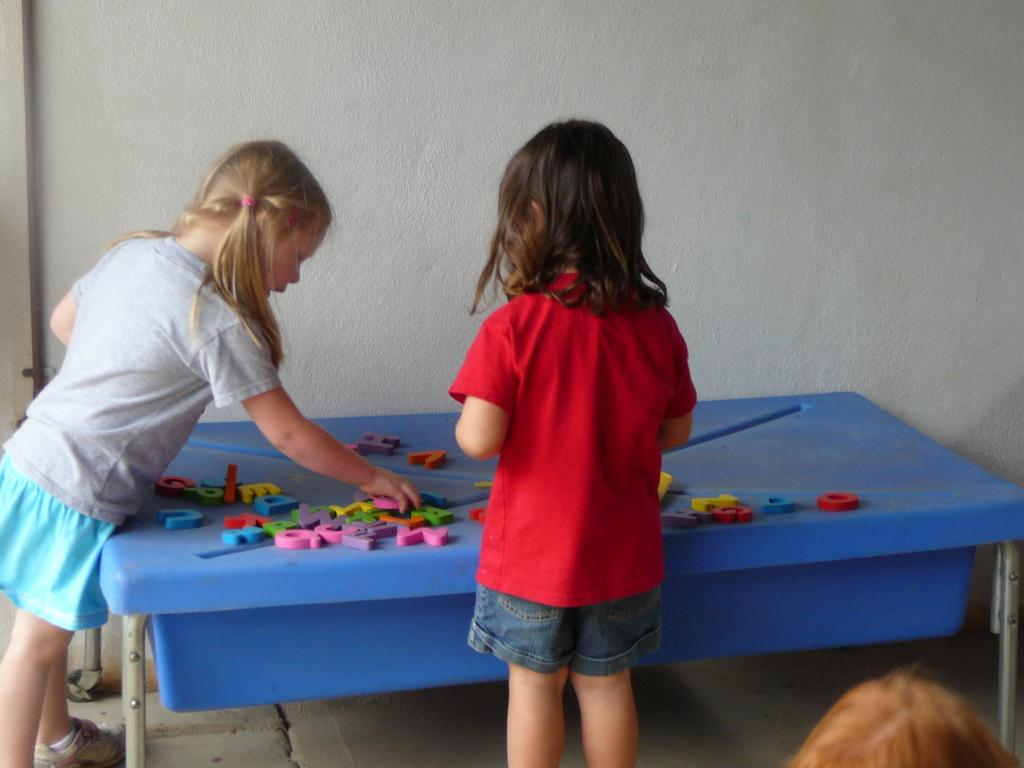What is the main object in the image? There is a table in the image. What is placed on the table? There are alphabet blocks on the table. Can you describe the alphabet blocks? The alphabet blocks are in different colors. Who is interacting with the alphabet blocks? Two girls are playing with the alphabet blocks. What can be seen in the background of the image? There is a wall in the background of the image. What type of pencil is the beginner using to draw on the sack in the image? There is no pencil, beginner, or sack present in the image. 